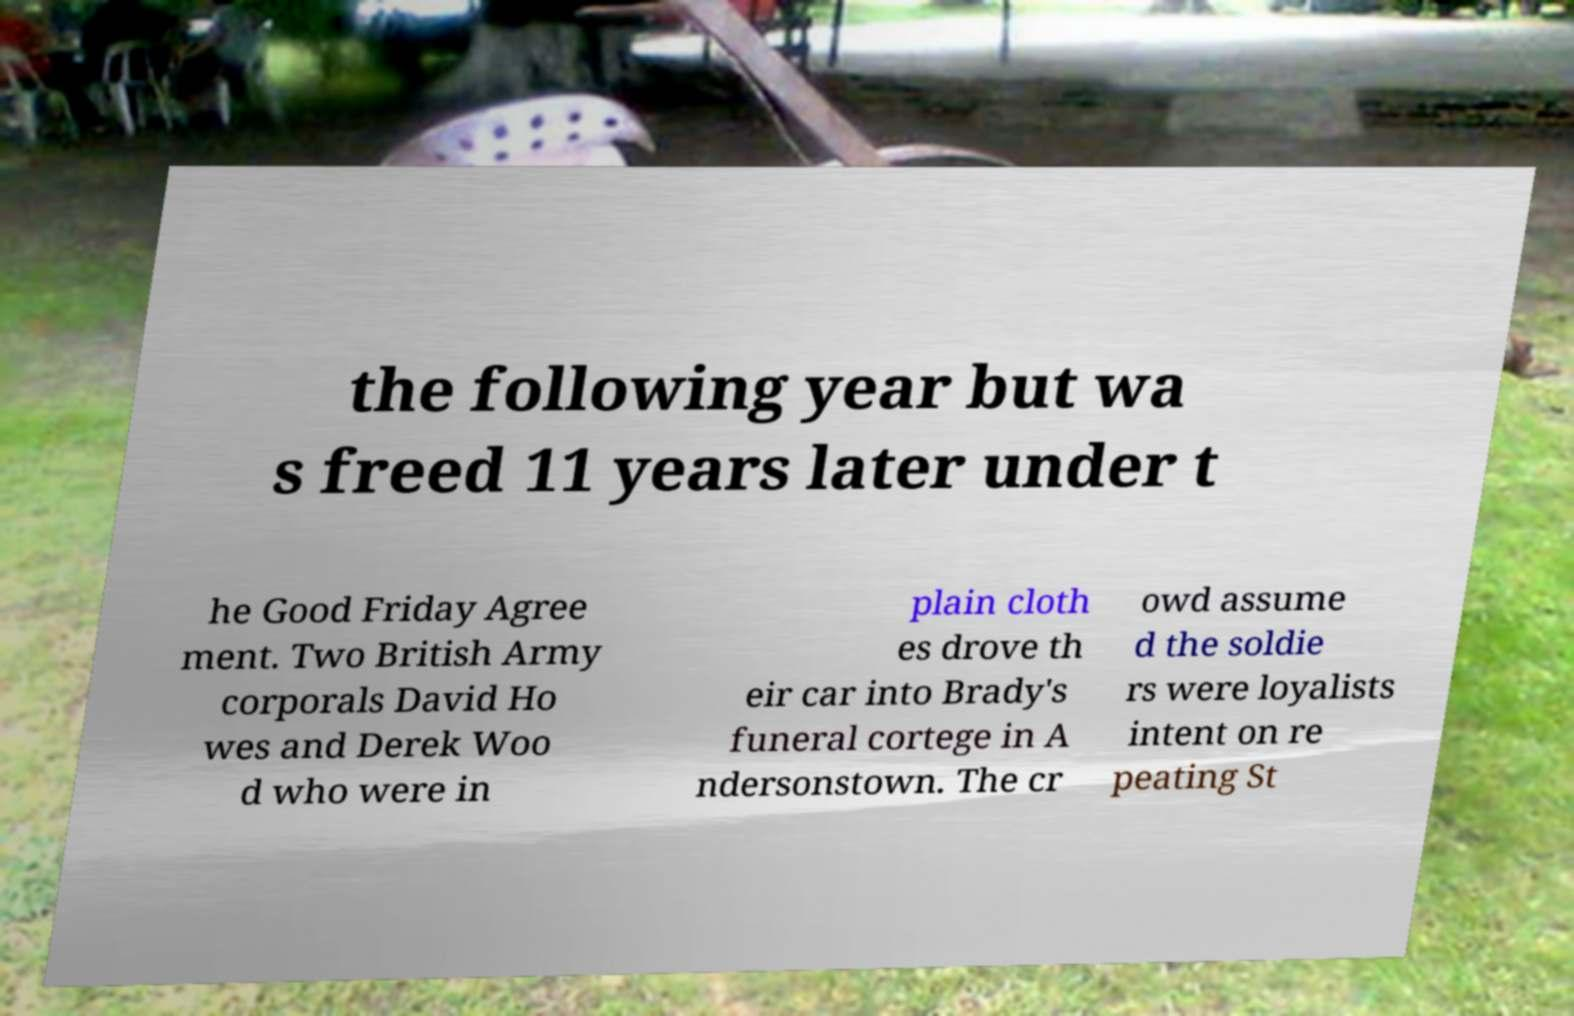I need the written content from this picture converted into text. Can you do that? the following year but wa s freed 11 years later under t he Good Friday Agree ment. Two British Army corporals David Ho wes and Derek Woo d who were in plain cloth es drove th eir car into Brady's funeral cortege in A ndersonstown. The cr owd assume d the soldie rs were loyalists intent on re peating St 